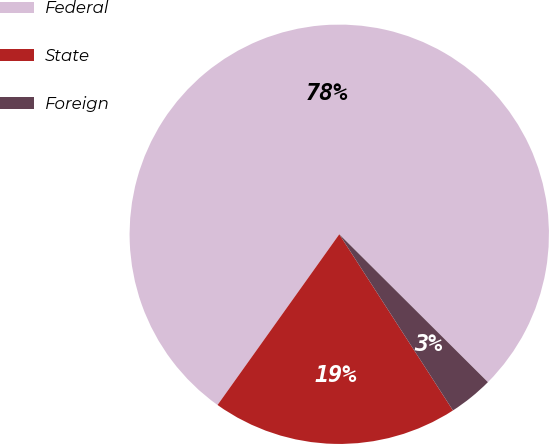<chart> <loc_0><loc_0><loc_500><loc_500><pie_chart><fcel>Federal<fcel>State<fcel>Foreign<nl><fcel>77.6%<fcel>18.98%<fcel>3.42%<nl></chart> 